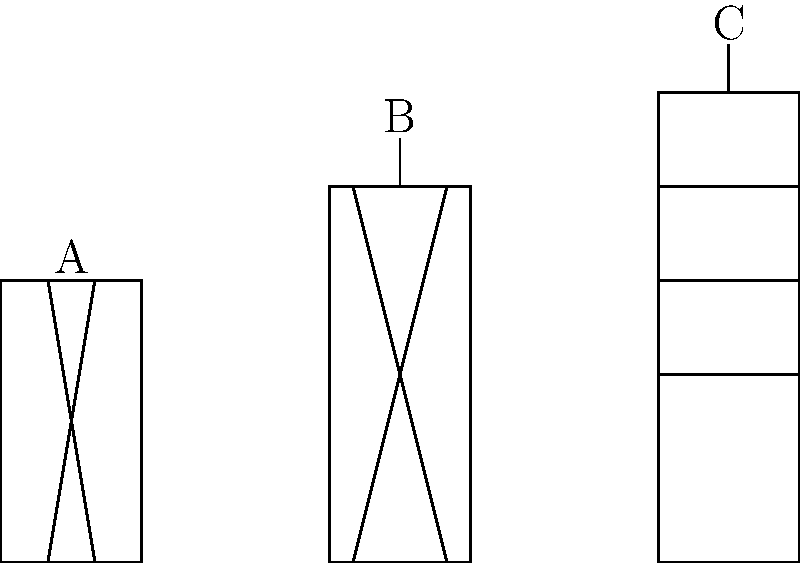Based on the schematic diagrams of blast furnaces shown above, which type represents the most modern and efficient design used in large-scale industrial steel production? To answer this question, we need to analyze the features of each blast furnace diagram:

1. Furnace A:
   - Simple, narrow design
   - No visible separate layers or sections
   - Resembles an ancient bloomery used in early iron production

2. Furnace B:
   - Taller and wider than A
   - Has a single opening at the top
   - Represents an early modern blast furnace design

3. Furnace C:
   - Tallest and widest design
   - Multiple horizontal layers or sections
   - Top section with a central opening
   - Most complex internal structure

The evolution of blast furnaces has been towards larger, more efficient designs with better heat distribution and more controlled reactions. The most modern blast furnaces have distinct zones for different stages of the iron-making process, which is evident in Furnace C.

The multiple horizontal sections in Furnace C likely represent:
- The top section for charging raw materials
- The stack or shaft where initial heating occurs
- The bosh where materials begin to melt
- The hearth at the bottom where molten iron collects

This design allows for better control of the smelting process, higher temperatures, and increased production capacity, making it the most efficient for large-scale industrial steel production.
Answer: Furnace C 